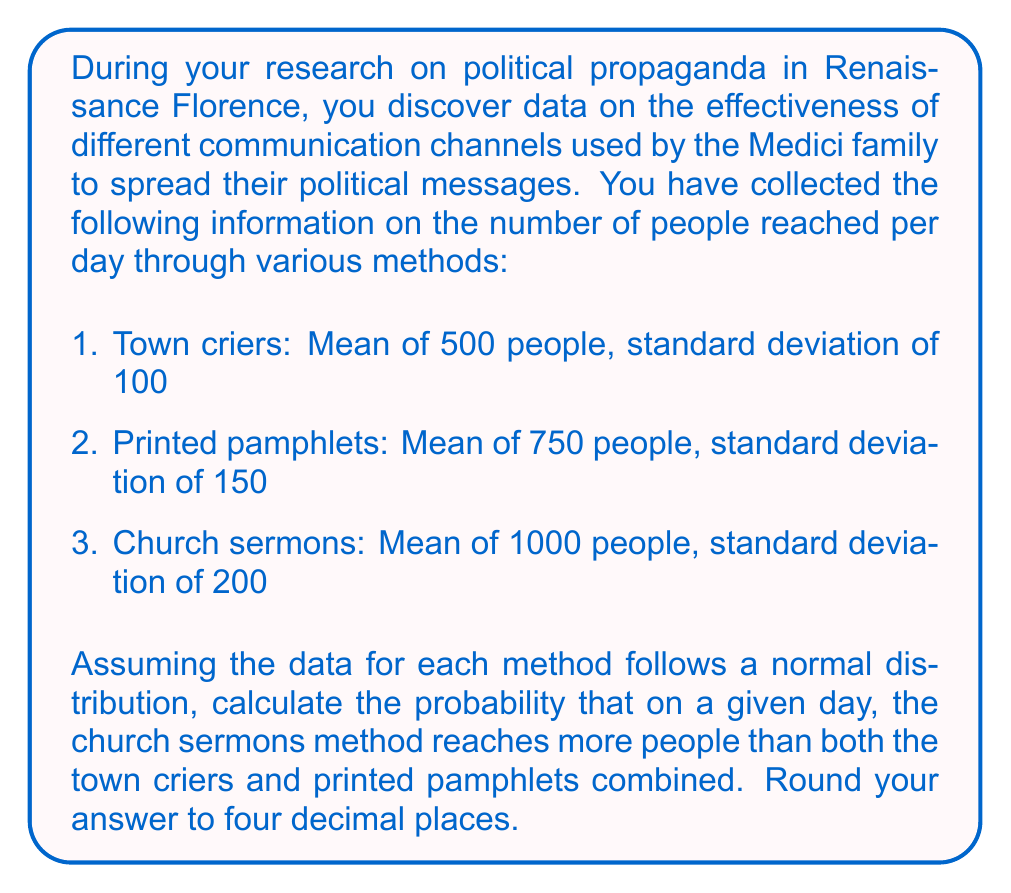Help me with this question. To solve this problem, we need to follow these steps:

1. Calculate the combined mean and standard deviation for town criers and printed pamphlets.
2. Find the difference between the church sermons and the combined methods.
3. Standardize this difference and use the standard normal distribution to calculate the probability.

Step 1: Combining town criers and printed pamphlets

The mean of the combined methods is the sum of their individual means:
$$\mu_{combined} = 500 + 750 = 1250$$

The variance of the combined methods is the sum of their individual variances:
$$\sigma^2_{combined} = 100^2 + 150^2 = 32,500$$

The standard deviation of the combined methods is the square root of the variance:
$$\sigma_{combined} = \sqrt{32,500} = 180.28$$

Step 2: Difference between church sermons and combined methods

Mean difference:
$$\mu_{diff} = \mu_{church} - \mu_{combined} = 1000 - 1250 = -250$$

Variance of the difference:
$$\sigma^2_{diff} = \sigma^2_{church} + \sigma^2_{combined} = 200^2 + 180.28^2 = 72,500$$

Standard deviation of the difference:
$$\sigma_{diff} = \sqrt{72,500} = 269.26$$

Step 3: Standardizing and calculating probability

We want to find $P(X > 0)$ where $X$ is the difference between church sermons and the combined methods.

Standardizing:
$$Z = \frac{X - \mu_{diff}}{\sigma_{diff}} = \frac{0 - (-250)}{269.26} = 0.9285$$

Using the standard normal distribution table or calculator, we find:
$$P(Z > 0.9285) = 1 - \Phi(0.9285) = 0.1766$$

Where $\Phi(z)$ is the cumulative distribution function of the standard normal distribution.
Answer: 0.1766 